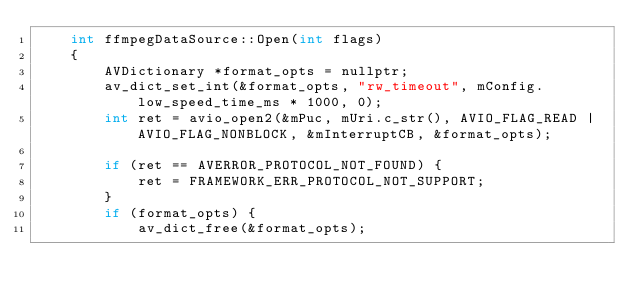Convert code to text. <code><loc_0><loc_0><loc_500><loc_500><_C++_>    int ffmpegDataSource::Open(int flags)
    {
        AVDictionary *format_opts = nullptr;
        av_dict_set_int(&format_opts, "rw_timeout", mConfig.low_speed_time_ms * 1000, 0);
        int ret = avio_open2(&mPuc, mUri.c_str(), AVIO_FLAG_READ | AVIO_FLAG_NONBLOCK, &mInterruptCB, &format_opts);

        if (ret == AVERROR_PROTOCOL_NOT_FOUND) {
            ret = FRAMEWORK_ERR_PROTOCOL_NOT_SUPPORT;
        }
        if (format_opts) {
            av_dict_free(&format_opts);</code> 